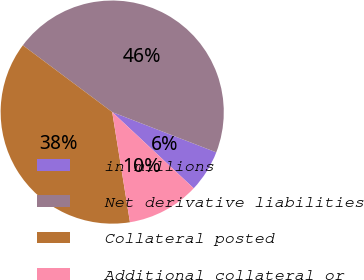Convert chart to OTSL. <chart><loc_0><loc_0><loc_500><loc_500><pie_chart><fcel>in millions<fcel>Net derivative liabilities<fcel>Collateral posted<fcel>Additional collateral or<nl><fcel>6.09%<fcel>45.66%<fcel>37.76%<fcel>10.49%<nl></chart> 